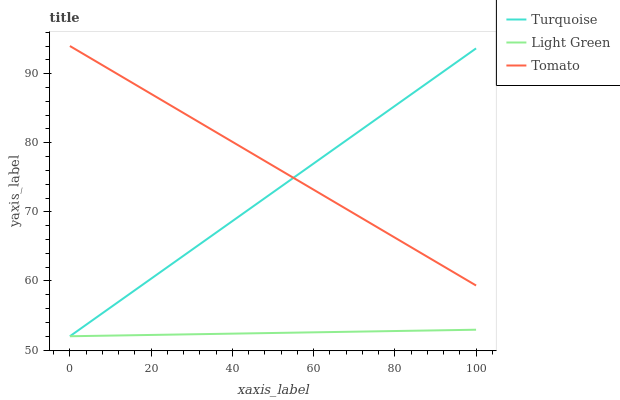Does Light Green have the minimum area under the curve?
Answer yes or no. Yes. Does Tomato have the maximum area under the curve?
Answer yes or no. Yes. Does Turquoise have the minimum area under the curve?
Answer yes or no. No. Does Turquoise have the maximum area under the curve?
Answer yes or no. No. Is Light Green the smoothest?
Answer yes or no. Yes. Is Turquoise the roughest?
Answer yes or no. Yes. Is Turquoise the smoothest?
Answer yes or no. No. Is Light Green the roughest?
Answer yes or no. No. Does Tomato have the highest value?
Answer yes or no. Yes. Does Turquoise have the highest value?
Answer yes or no. No. Is Light Green less than Tomato?
Answer yes or no. Yes. Is Tomato greater than Light Green?
Answer yes or no. Yes. Does Tomato intersect Turquoise?
Answer yes or no. Yes. Is Tomato less than Turquoise?
Answer yes or no. No. Is Tomato greater than Turquoise?
Answer yes or no. No. Does Light Green intersect Tomato?
Answer yes or no. No. 